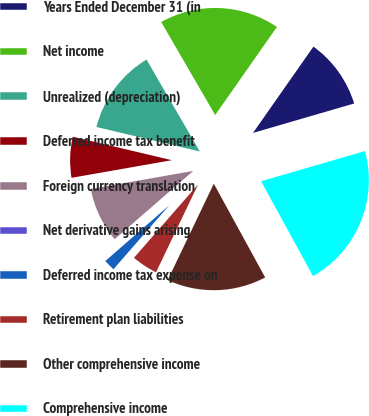Convert chart. <chart><loc_0><loc_0><loc_500><loc_500><pie_chart><fcel>Years Ended December 31 (in<fcel>Net income<fcel>Unrealized (depreciation)<fcel>Deferred income tax benefit<fcel>Foreign currency translation<fcel>Net derivative gains arising<fcel>Deferred income tax expense on<fcel>Retirement plan liabilities<fcel>Other comprehensive income<fcel>Comprehensive income<nl><fcel>10.77%<fcel>18.09%<fcel>12.93%<fcel>6.47%<fcel>8.62%<fcel>0.02%<fcel>2.17%<fcel>4.32%<fcel>15.08%<fcel>21.53%<nl></chart> 